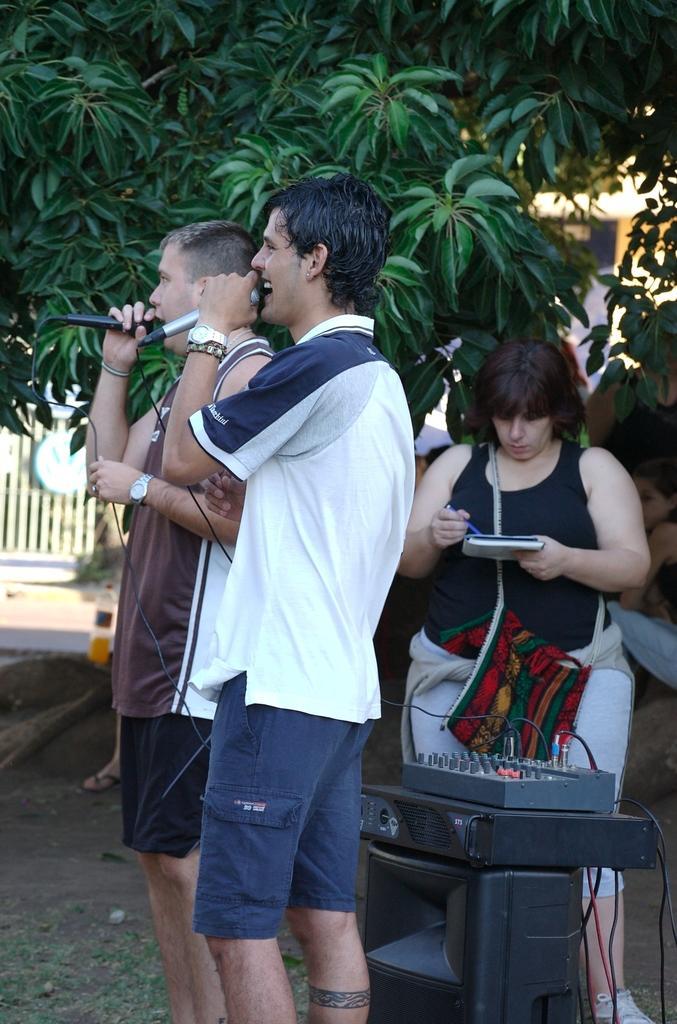How would you summarize this image in a sentence or two? In the image there are two men singing on mic and behind them there is a woman writing on a book, in front of her there is an amplifier on a table and over the background there is a tree. 